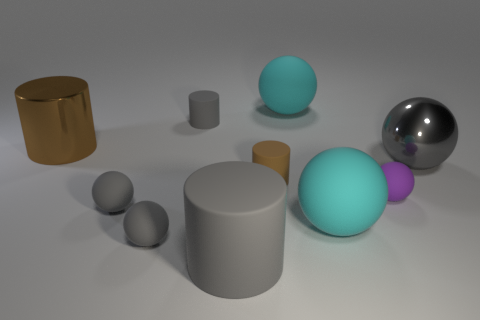How many gray spheres must be subtracted to get 1 gray spheres? 2 Subtract all large matte cylinders. How many cylinders are left? 3 Subtract all purple spheres. How many gray cylinders are left? 2 Subtract 4 cylinders. How many cylinders are left? 0 Subtract 0 red cubes. How many objects are left? 10 Subtract all balls. How many objects are left? 4 Subtract all blue cylinders. Subtract all gray cubes. How many cylinders are left? 4 Subtract all gray metallic spheres. Subtract all cyan spheres. How many objects are left? 7 Add 2 tiny spheres. How many tiny spheres are left? 5 Add 9 big gray matte cylinders. How many big gray matte cylinders exist? 10 